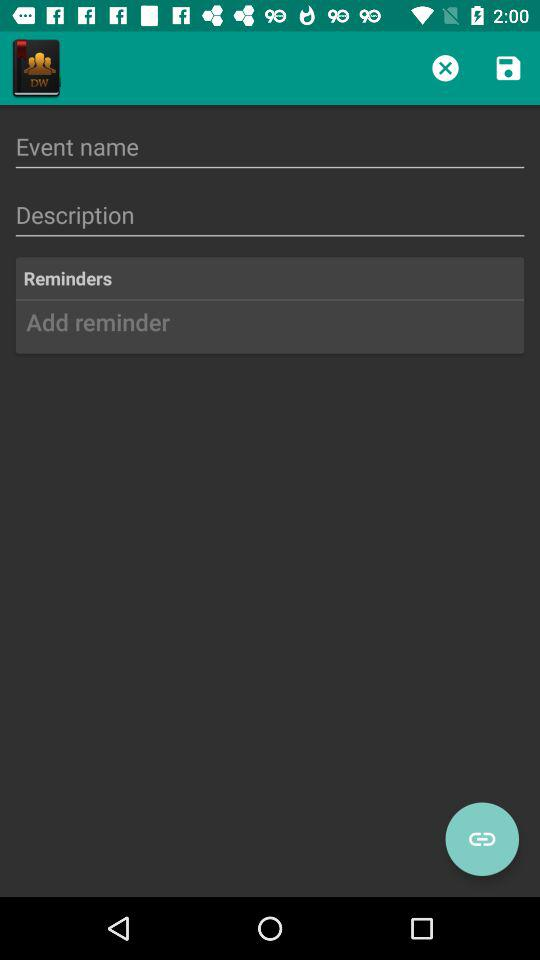How many fields are there for adding an event?
Answer the question using a single word or phrase. 3 